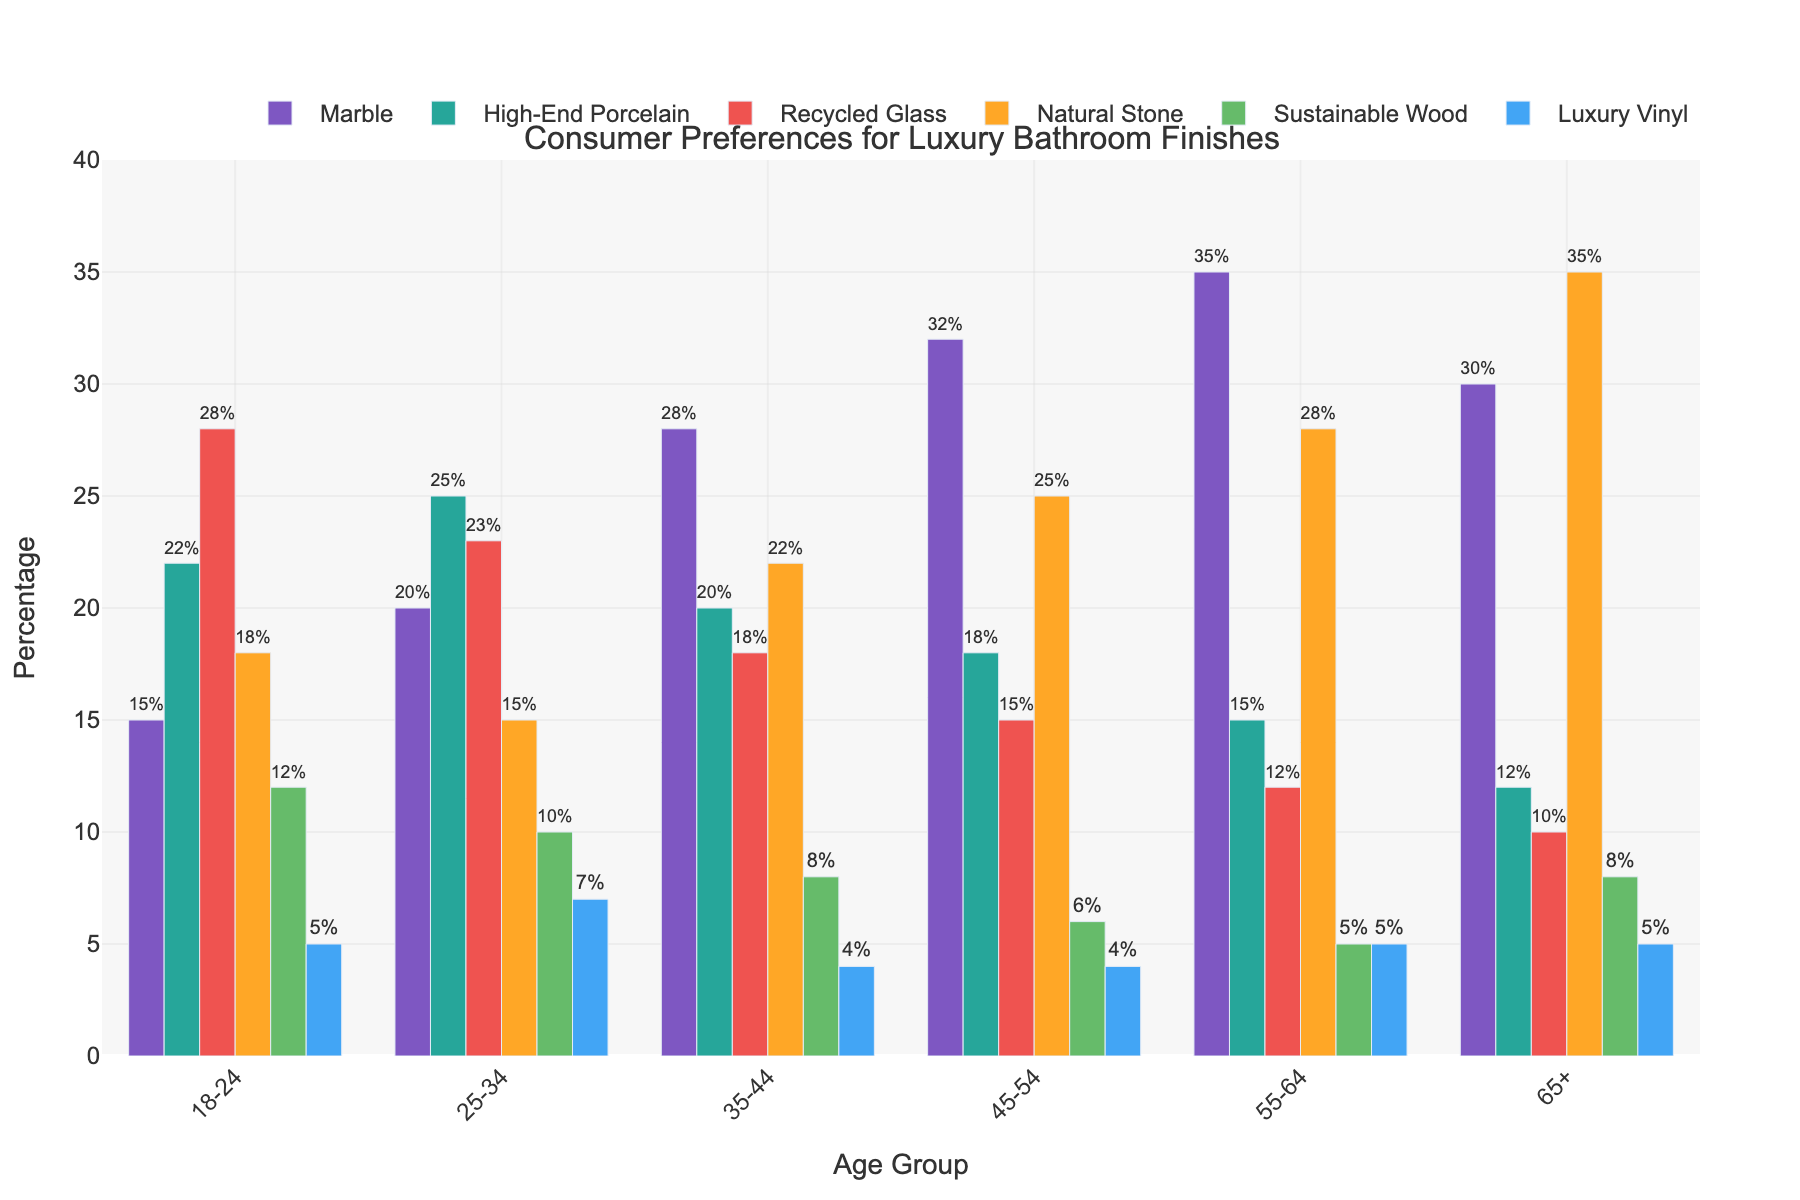What is the most preferred luxury bathroom finish for the age group 18-24? By examining the bars for the age group 18-24, the highest bar represents "Recycled Glass" at 28%.
Answer: Recycled Glass Which age group has the highest preference for Natural Stone? Looking at the heights of the bars representing "Natural Stone" across all age groups, the highest bar is for the age group 65+ with a percentage of 35%.
Answer: 65+ How does the preference for Sustainable Wood change as the age group increases from 18-24 to 65+? By examining the heights of the bars for "Sustainable Wood" from 18-24 to 65+, the percentages decrease: 12% (18-24), 10% (25-34), 8% (35-44), 6% (45-54), 5% (55-64), and 8% (65+).
Answer: Decreases then stabilizes Which material shows the greatest variance in preference across different age groups? Looking at the range of bar heights for each material, "Natural Stone" shows the greatest variance, ranging from 18% to 35%.
Answer: Natural Stone For the age group 35-44, what is the difference in preference between Marble and High-End Porcelain? For the age group 35-44, Marble is preferred by 28% and High-End Porcelain by 20%. The difference is 28% - 20% = 8%.
Answer: 8% What is the least preferred luxury bathroom finish by the age group 55-64? By examining the bars for the age group 55-64, the shortest bar represents "Sustainable Wood" at 5%.
Answer: Sustainable Wood Which two age groups show equal preference for Luxury Vinyl? By comparing the heights of the bars for "Luxury Vinyl" across the age groups, both the age groups 45-54 and 55-64 have a preference of 5%.
Answer: 45-54 and 55-64 What is the average preference percentage for Marble across all age groups? Summing the percentages for Marble across all age groups: 15% + 20% + 28% + 32% + 35% + 30% = 160%. The average is 160% / 6 = 26.67%.
Answer: 26.67% If you combine the preferences for Recycled Glass and Luxury Vinyl for the age group 18-24, what is the total? For the age group 18-24, Recycled Glass is 28% and Luxury Vinyl is 5%. The combined total is 28% + 5% = 33%.
Answer: 33% What is the preference ratio of High-End Porcelain to Sustainable Wood for the age group 25-34? For the age group 25-34, High-End Porcelain is 25% and Sustainable Wood is 10%. The ratio is 25% / 10% = 2.5.
Answer: 2.5 